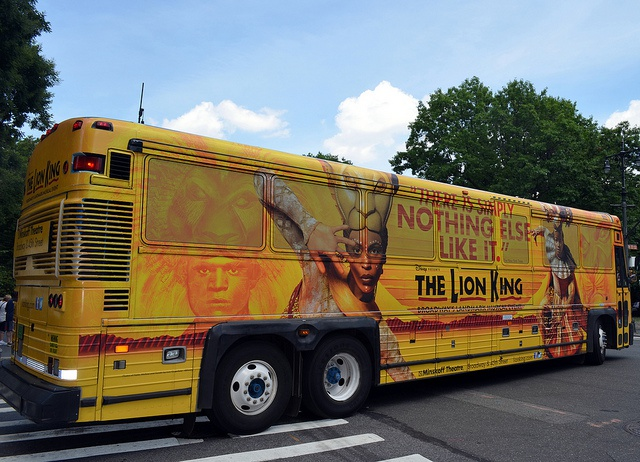Describe the objects in this image and their specific colors. I can see bus in black, olive, and maroon tones in this image. 